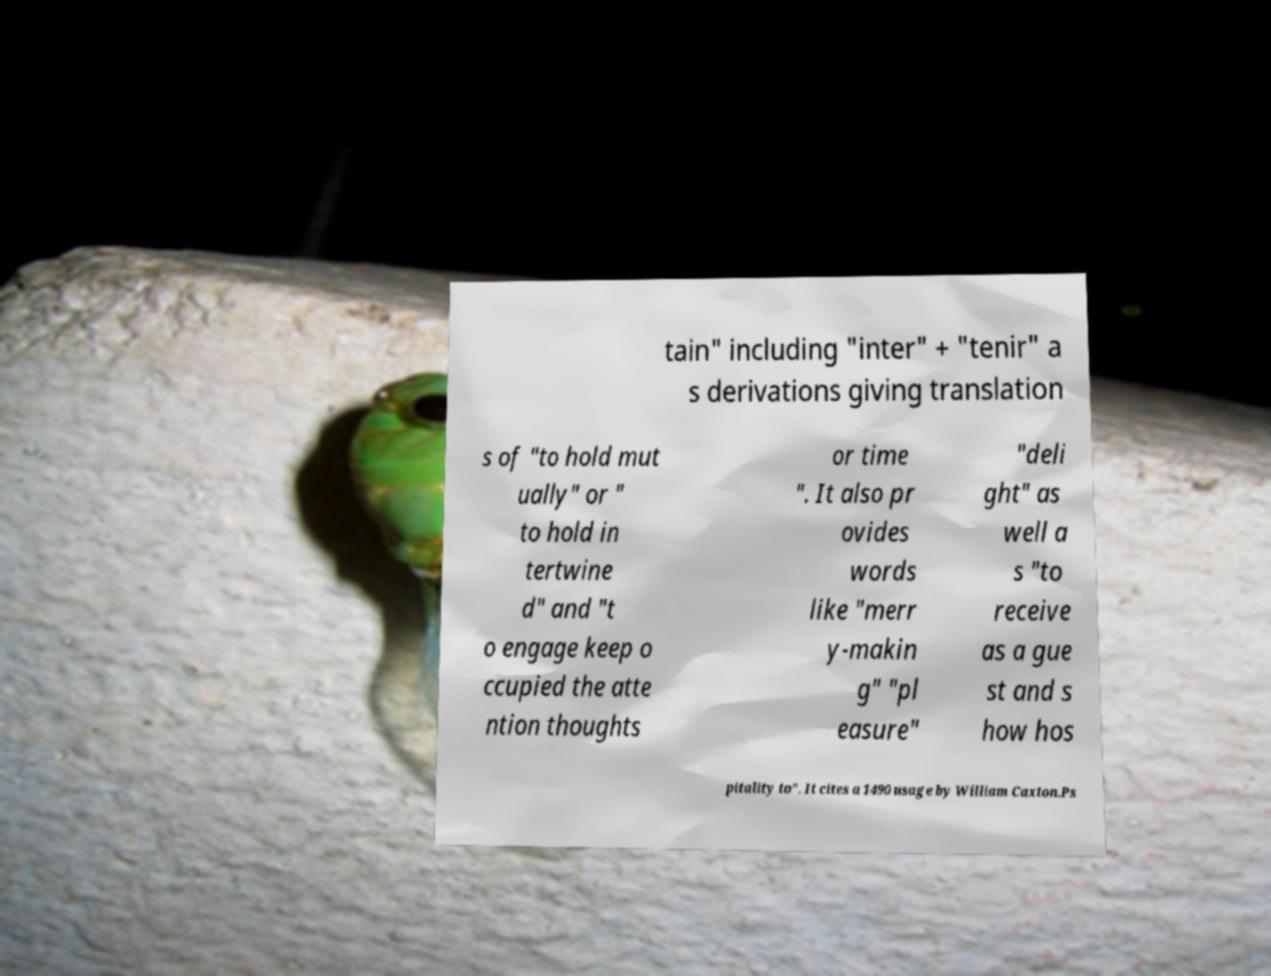Can you accurately transcribe the text from the provided image for me? tain" including "inter" + "tenir" a s derivations giving translation s of "to hold mut ually" or " to hold in tertwine d" and "t o engage keep o ccupied the atte ntion thoughts or time ". It also pr ovides words like "merr y-makin g" "pl easure" "deli ght" as well a s "to receive as a gue st and s how hos pitality to". It cites a 1490 usage by William Caxton.Ps 